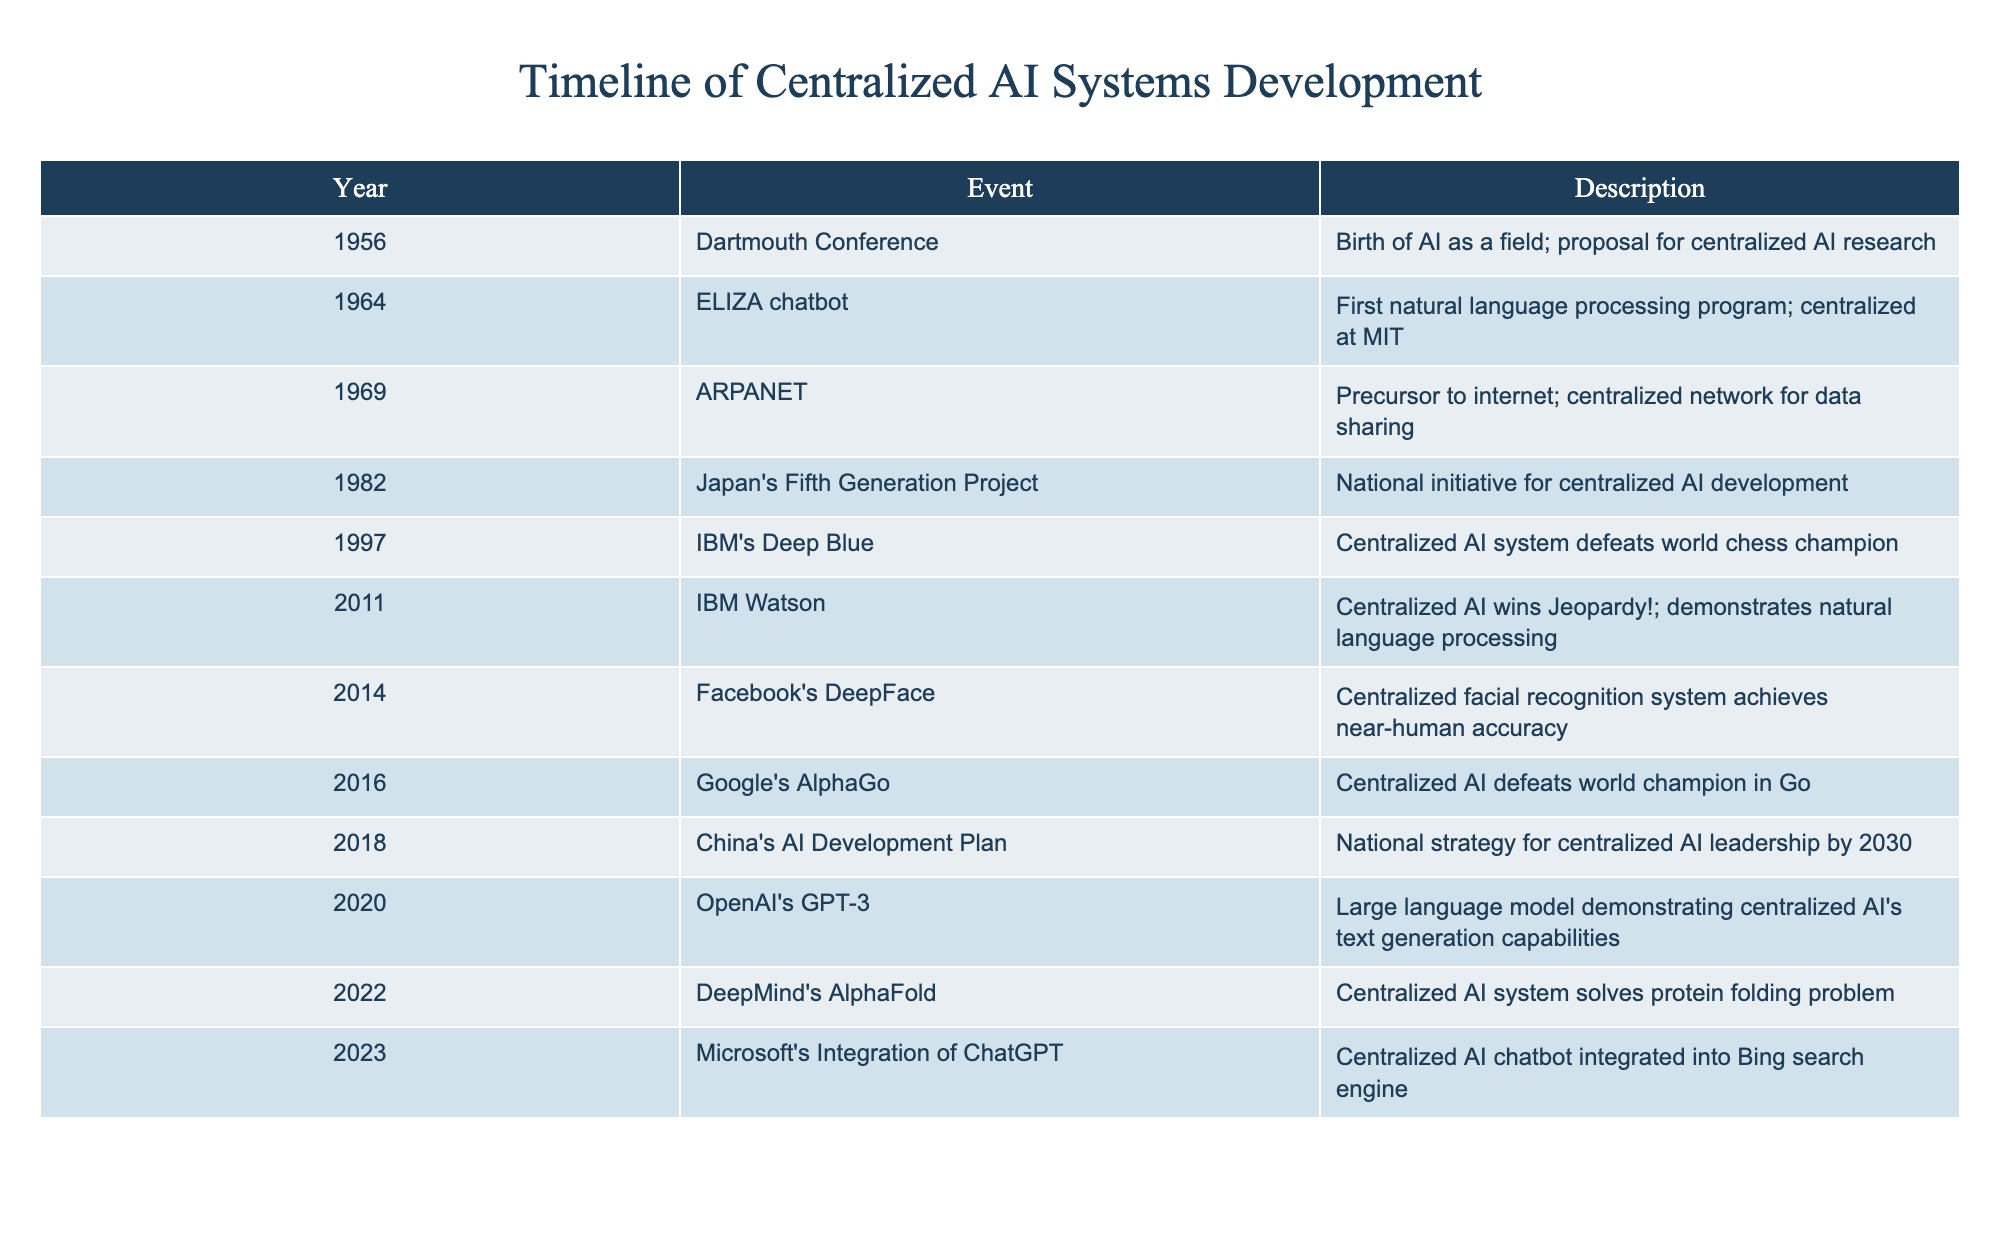What year did IBM's Deep Blue defeat the world chess champion? The table shows that IBM's Deep Blue event occurred in the year 1997.
Answer: 1997 What was the first centralized AI system mentioned in the timeline? According to the table, the first centralized AI system noted is the ELIZA chatbot, which was developed in 1964.
Answer: ELIZA chatbot How many years apart were the events of the Dartmouth Conference and IBM's Watson winning Jeopardy? The Dartmouth Conference took place in 1956 and IBM's Watson won Jeopardy in 2011. The difference between these two years is 2011 - 1956 = 55 years.
Answer: 55 years Is Facebook's DeepFace a non-centralized AI system? The table indicates that Facebook's DeepFace is indeed a centralized facial recognition system, so the statement is false.
Answer: No What is the average year of the events listed in the timeline? To find the average year, we add all the years (1956 + 1964 + 1969 + 1982 + 1997 + 2011 + 2014 + 2016 + 2018 + 2020 + 2022 + 2023) which equals 22826 and then divide by the number of events, which is 12. This gives us an average year of 22826 / 12 = 1902.17, rounded to 2013.
Answer: 2013 What centralized AI system defeated a world champion in Go? The event for the centralized AI system that defeated a world champion in Go is listed as Google's AlphaGo in 2016.
Answer: Google's AlphaGo Did Japan's Fifth Generation Project initiate the development of AI in the 1980s? The timeline confirms that Japan's Fifth Generation Project was a national initiative for centralized AI development in 1982, making the statement true.
Answer: Yes Which AI system was integrated into a search engine in 2023? According to the table, Microsoft's integration of ChatGPT into the Bing search engine occurred in 2023.
Answer: ChatGPT 